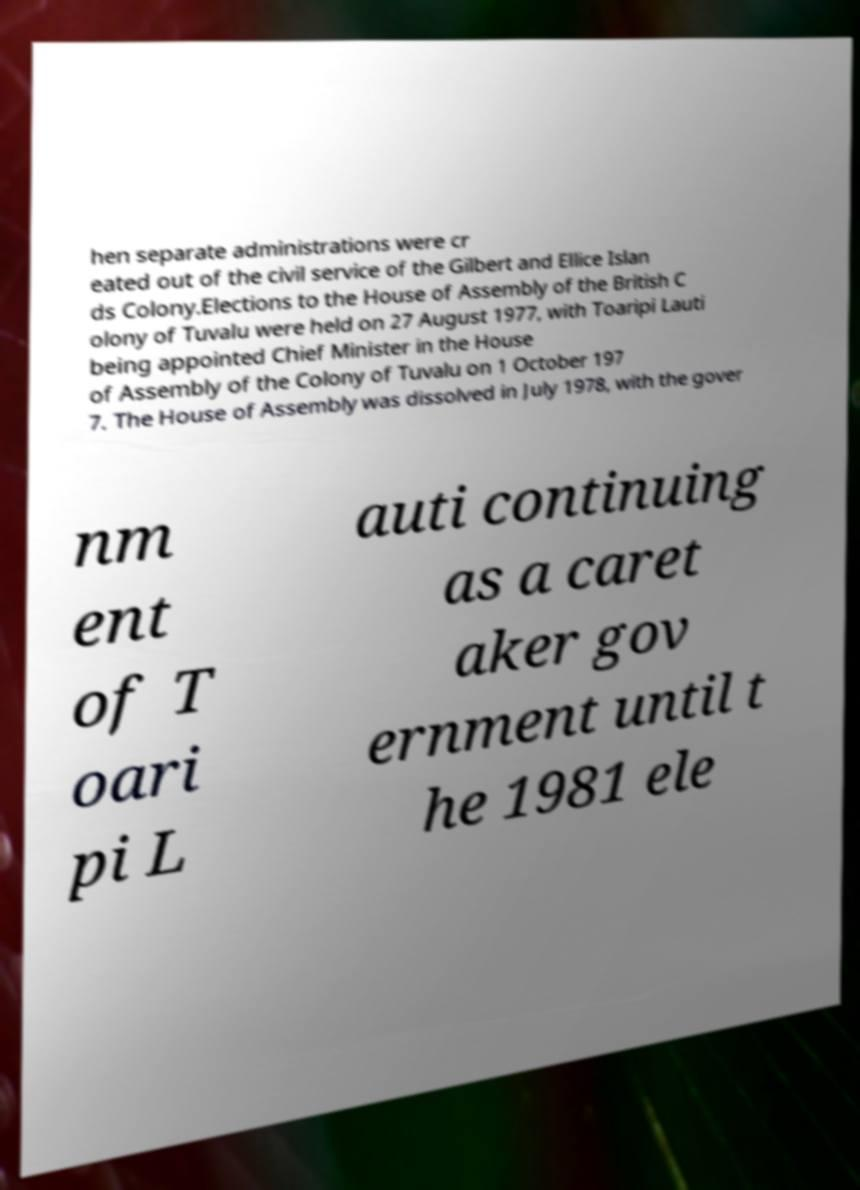Please read and relay the text visible in this image. What does it say? hen separate administrations were cr eated out of the civil service of the Gilbert and Ellice Islan ds Colony.Elections to the House of Assembly of the British C olony of Tuvalu were held on 27 August 1977, with Toaripi Lauti being appointed Chief Minister in the House of Assembly of the Colony of Tuvalu on 1 October 197 7. The House of Assembly was dissolved in July 1978, with the gover nm ent of T oari pi L auti continuing as a caret aker gov ernment until t he 1981 ele 